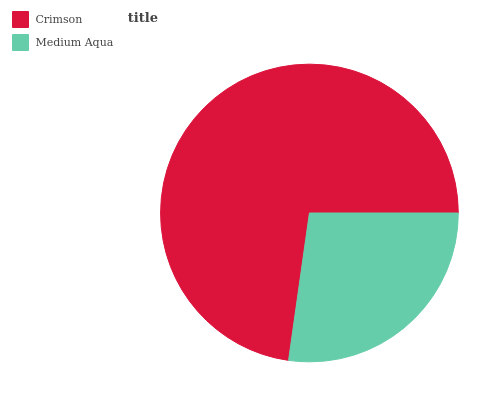Is Medium Aqua the minimum?
Answer yes or no. Yes. Is Crimson the maximum?
Answer yes or no. Yes. Is Medium Aqua the maximum?
Answer yes or no. No. Is Crimson greater than Medium Aqua?
Answer yes or no. Yes. Is Medium Aqua less than Crimson?
Answer yes or no. Yes. Is Medium Aqua greater than Crimson?
Answer yes or no. No. Is Crimson less than Medium Aqua?
Answer yes or no. No. Is Crimson the high median?
Answer yes or no. Yes. Is Medium Aqua the low median?
Answer yes or no. Yes. Is Medium Aqua the high median?
Answer yes or no. No. Is Crimson the low median?
Answer yes or no. No. 